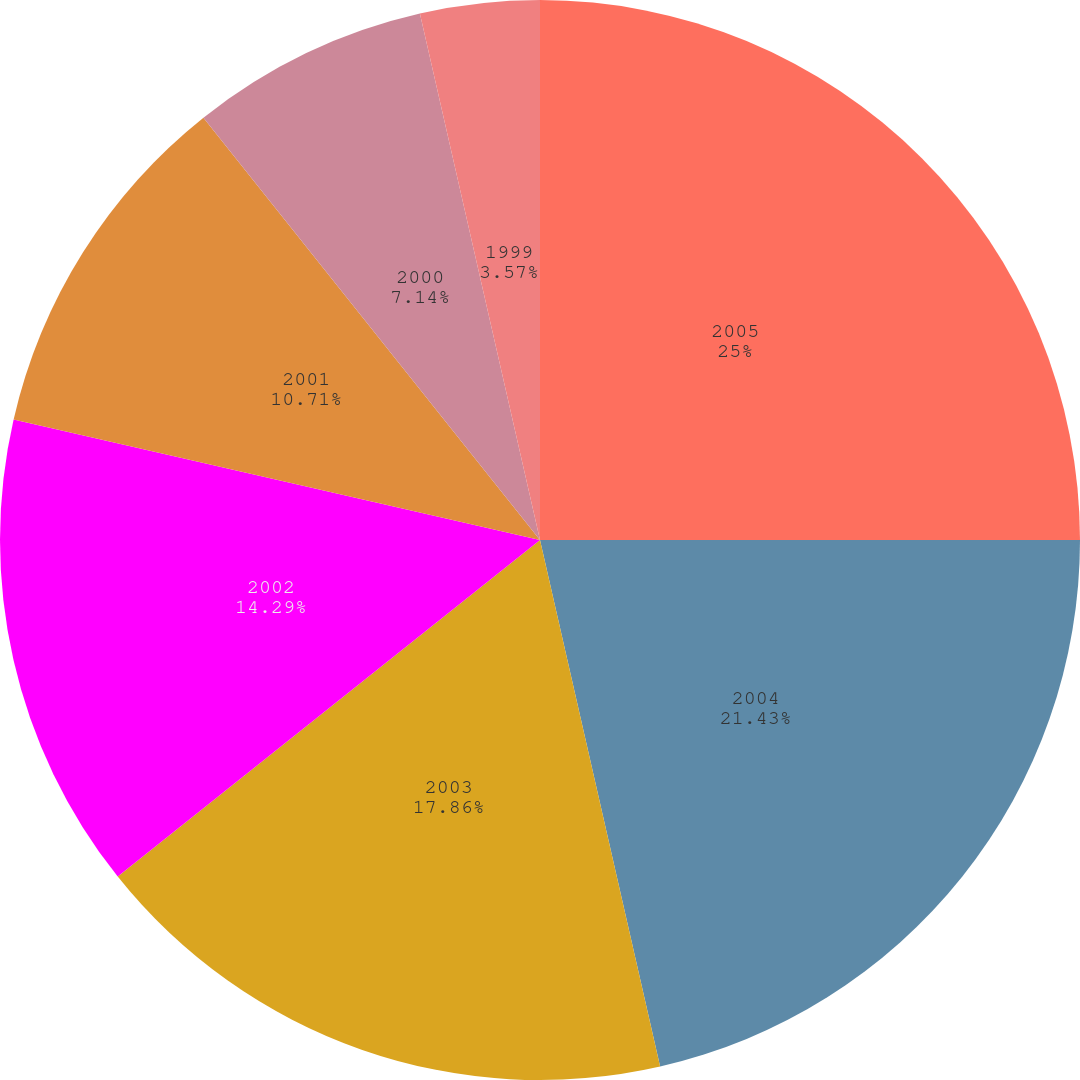Convert chart to OTSL. <chart><loc_0><loc_0><loc_500><loc_500><pie_chart><fcel>2005<fcel>2004<fcel>2003<fcel>2002<fcel>2001<fcel>2000<fcel>1999<nl><fcel>25.0%<fcel>21.43%<fcel>17.86%<fcel>14.29%<fcel>10.71%<fcel>7.14%<fcel>3.57%<nl></chart> 